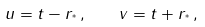<formula> <loc_0><loc_0><loc_500><loc_500>u = t - r _ { ^ { * } } \, , \quad v = t + r _ { ^ { * } } \, ,</formula> 